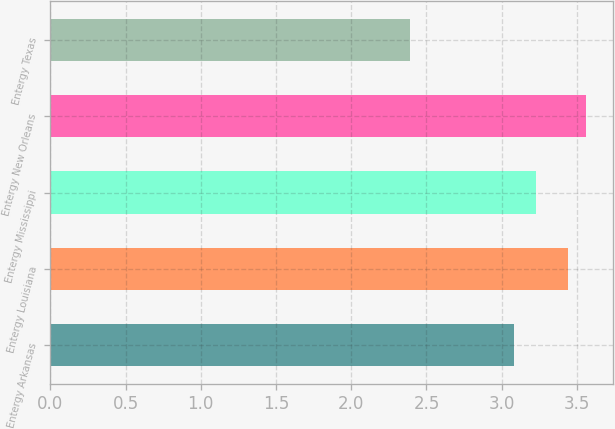Convert chart to OTSL. <chart><loc_0><loc_0><loc_500><loc_500><bar_chart><fcel>Entergy Arkansas<fcel>Entergy Louisiana<fcel>Entergy Mississippi<fcel>Entergy New Orleans<fcel>Entergy Texas<nl><fcel>3.08<fcel>3.44<fcel>3.23<fcel>3.56<fcel>2.39<nl></chart> 